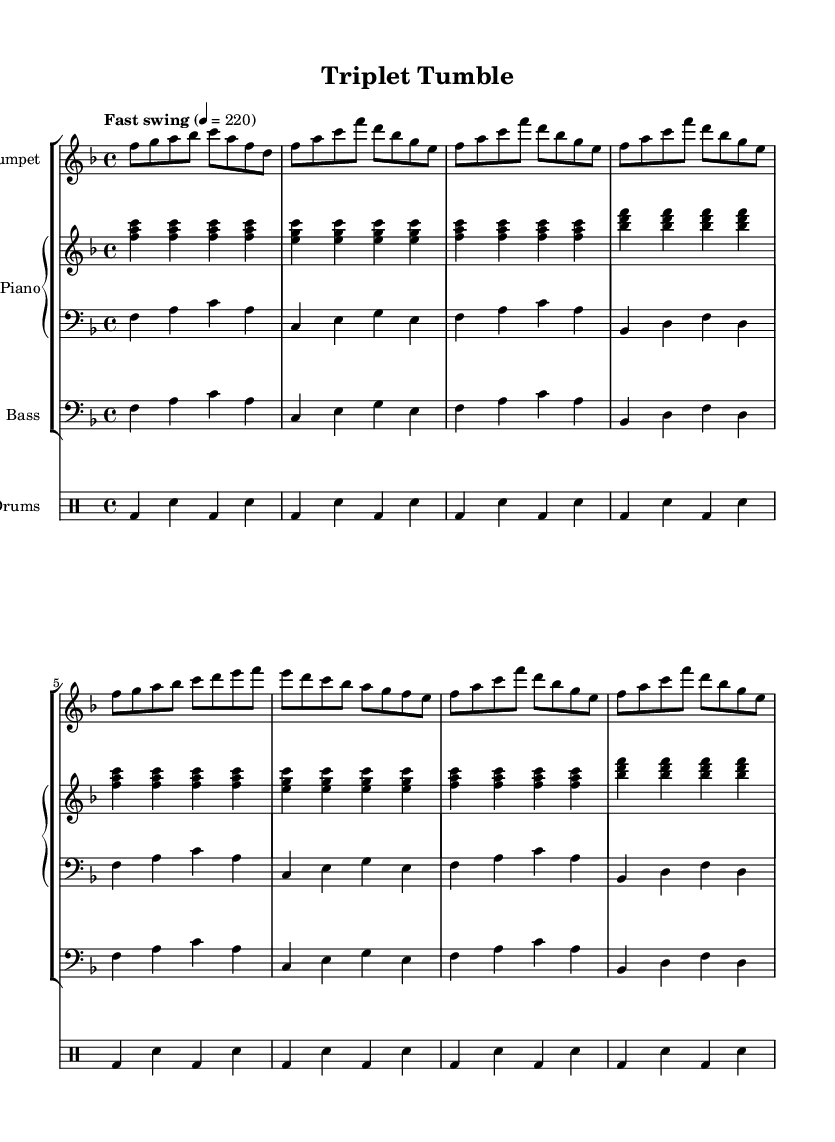What is the key signature of this music? The key signature is F major, which has one flat (B flat).
Answer: F major What is the time signature of this music? The time signature is four-four, which means there are four beats per measure.
Answer: Four-four What is the tempo marking for this piece? The tempo marking indicates a fast swing feel with a metronome marking of 220 beats per minute.
Answer: Fast swing, 220 How many measures are in the A section? The A section contains 8 measures, as inferred from the repeated thematic material.
Answer: 8 measures What is the main instrument in the trumpet part? The main instrument in the trumpet part is the trumpet itself, indicated at the beginning of its staff.
Answer: Trumpet How many times is the A section repeated? The A section is repeated twice in the provided music example.
Answer: Twice What type of jazz rhythm is used in the drums part? The drums part predominantly uses a swing rhythm, characterized by alternating bass drum and snare.
Answer: Swing rhythm 